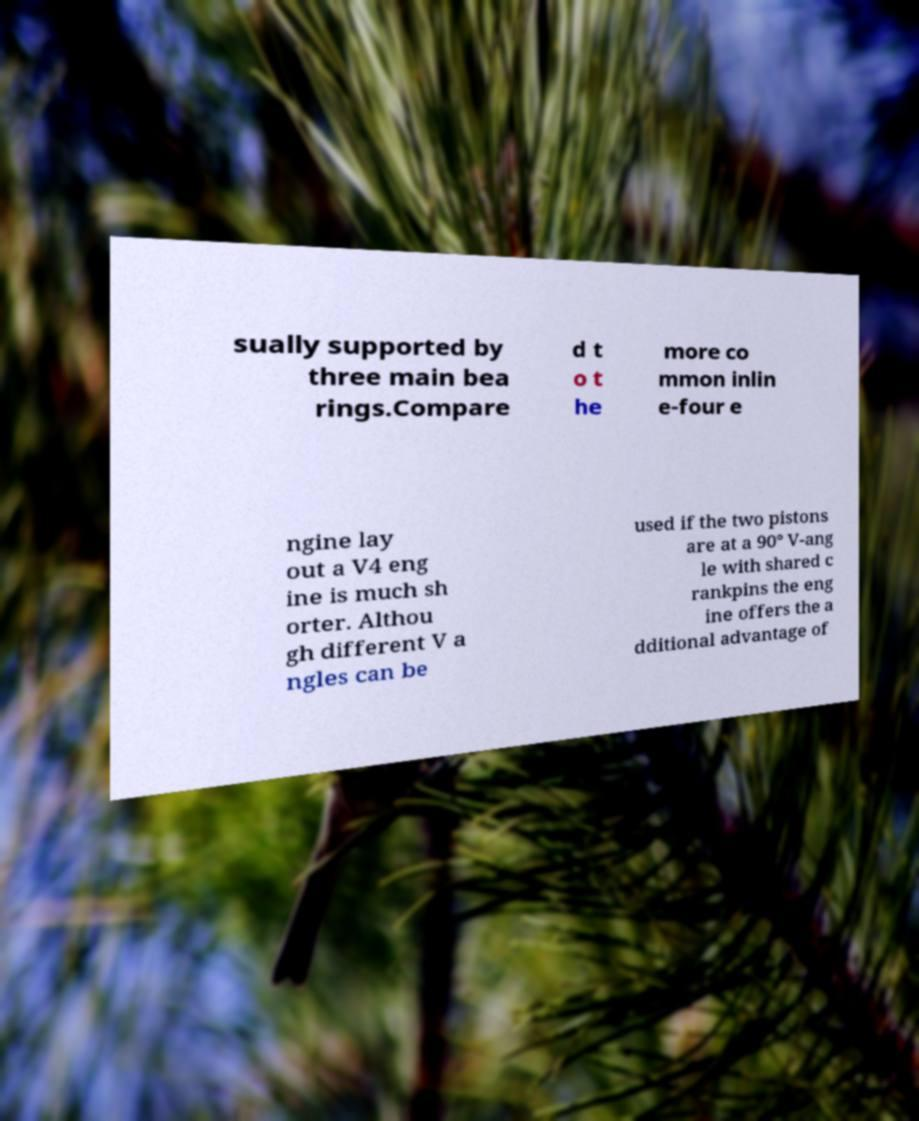Could you assist in decoding the text presented in this image and type it out clearly? sually supported by three main bea rings.Compare d t o t he more co mmon inlin e-four e ngine lay out a V4 eng ine is much sh orter. Althou gh different V a ngles can be used if the two pistons are at a 90° V-ang le with shared c rankpins the eng ine offers the a dditional advantage of 